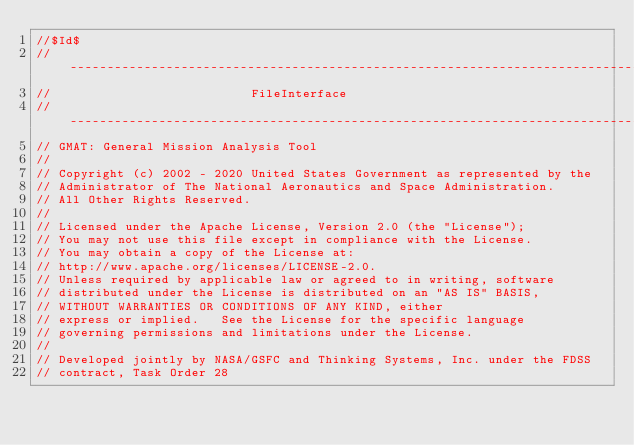Convert code to text. <code><loc_0><loc_0><loc_500><loc_500><_C++_>//$Id$
//------------------------------------------------------------------------------
//                           FileInterface
//------------------------------------------------------------------------------
// GMAT: General Mission Analysis Tool
//
// Copyright (c) 2002 - 2020 United States Government as represented by the
// Administrator of The National Aeronautics and Space Administration.
// All Other Rights Reserved.
//
// Licensed under the Apache License, Version 2.0 (the "License"); 
// You may not use this file except in compliance with the License. 
// You may obtain a copy of the License at:
// http://www.apache.org/licenses/LICENSE-2.0. 
// Unless required by applicable law or agreed to in writing, software
// distributed under the License is distributed on an "AS IS" BASIS,
// WITHOUT WARRANTIES OR CONDITIONS OF ANY KIND, either 
// express or implied.   See the License for the specific language
// governing permissions and limitations under the License.
//
// Developed jointly by NASA/GSFC and Thinking Systems, Inc. under the FDSS 
// contract, Task Order 28</code> 